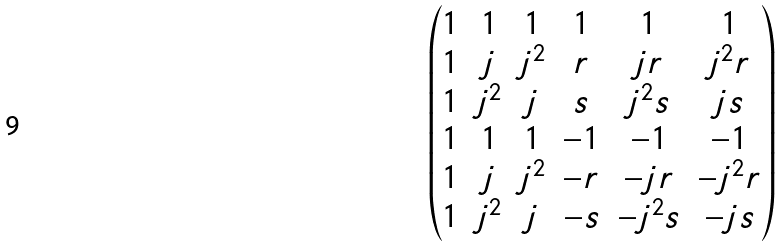Convert formula to latex. <formula><loc_0><loc_0><loc_500><loc_500>\begin{pmatrix} 1 & 1 & 1 & 1 & 1 & 1 \\ 1 & j & j ^ { 2 } & r & j r & j ^ { 2 } r \\ 1 & j ^ { 2 } & j & s & j ^ { 2 } s & j s \\ 1 & 1 & 1 & - 1 & - 1 & - 1 \\ 1 & j & j ^ { 2 } & - r & - j r & - j ^ { 2 } r \\ 1 & j ^ { 2 } & j & - s & - j ^ { 2 } s & - j s \end{pmatrix}</formula> 